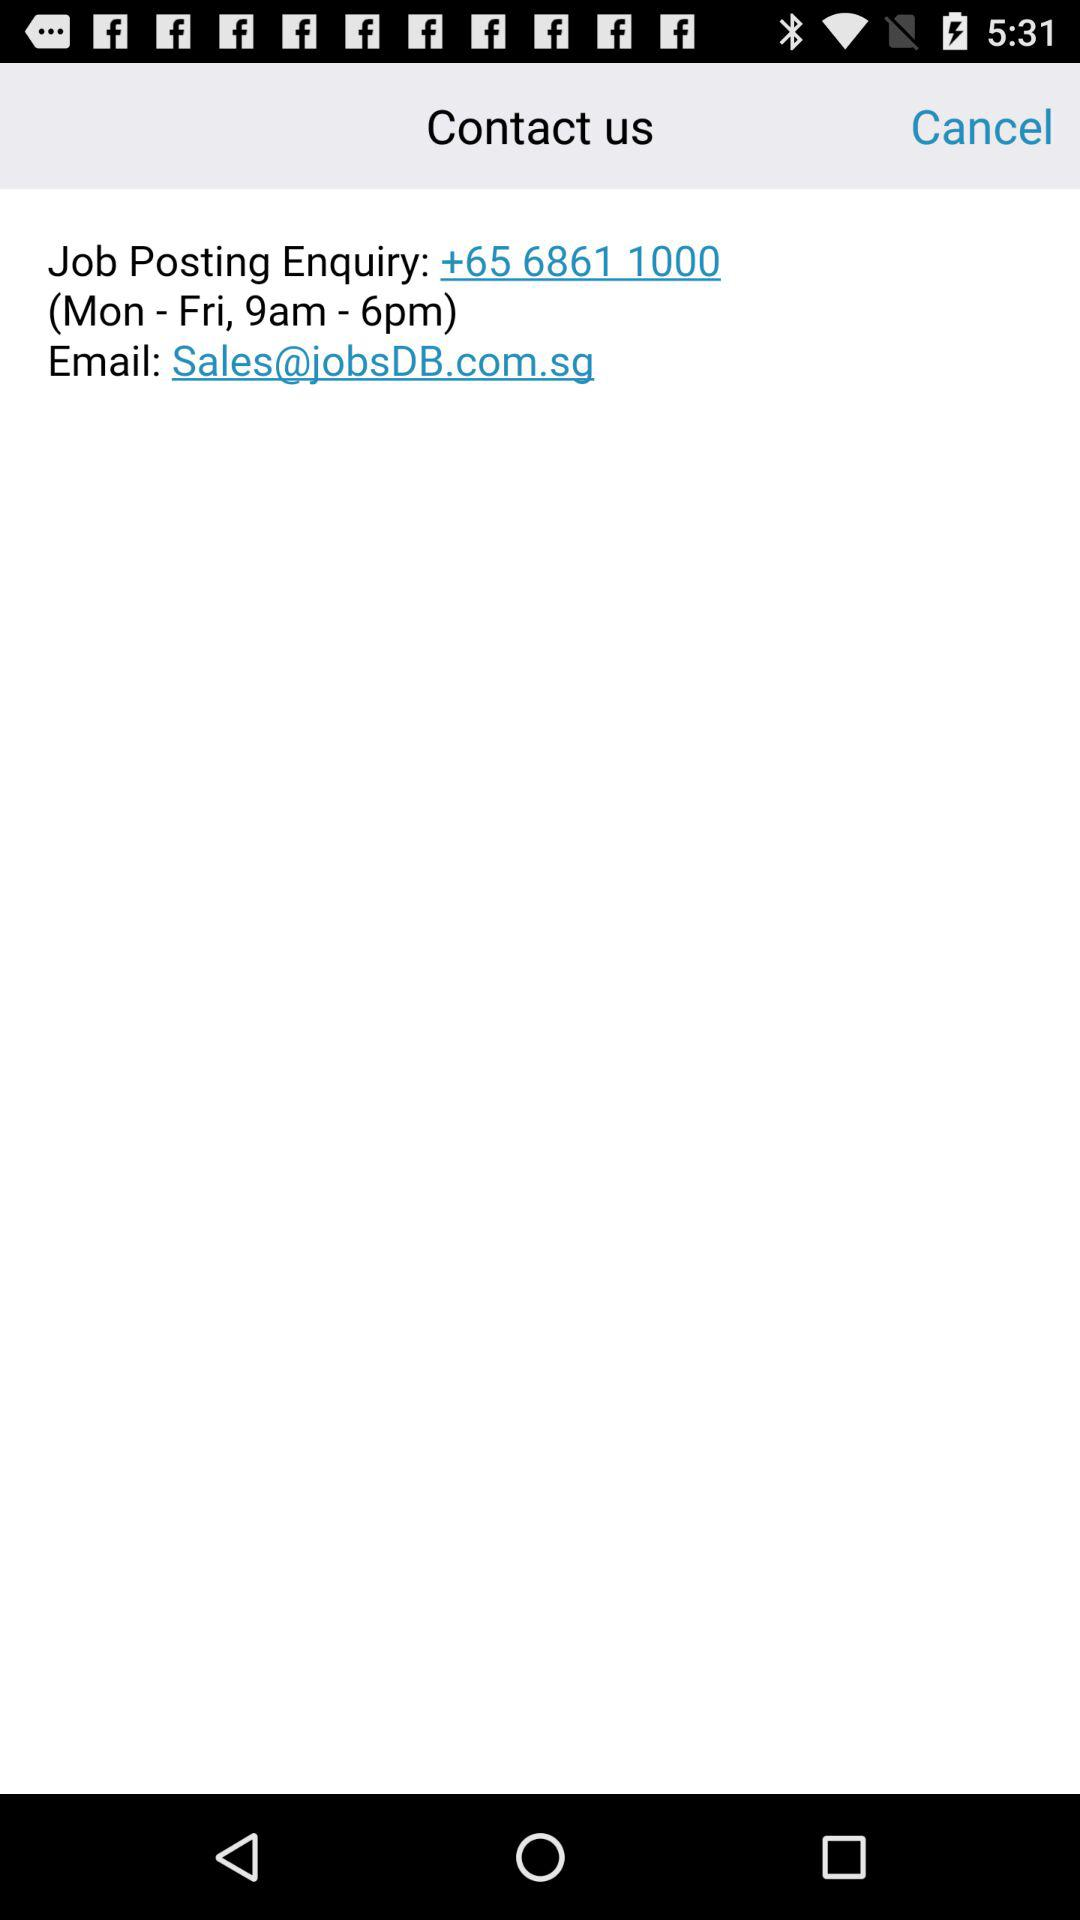What is the email address? The email address is Sales@jobsDB.com.sg. 